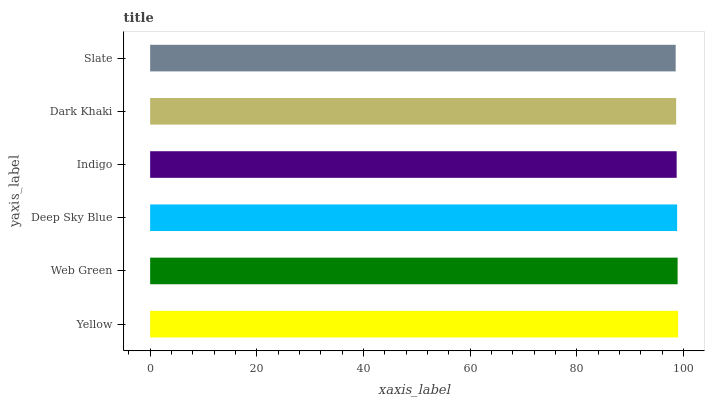Is Slate the minimum?
Answer yes or no. Yes. Is Yellow the maximum?
Answer yes or no. Yes. Is Web Green the minimum?
Answer yes or no. No. Is Web Green the maximum?
Answer yes or no. No. Is Yellow greater than Web Green?
Answer yes or no. Yes. Is Web Green less than Yellow?
Answer yes or no. Yes. Is Web Green greater than Yellow?
Answer yes or no. No. Is Yellow less than Web Green?
Answer yes or no. No. Is Deep Sky Blue the high median?
Answer yes or no. Yes. Is Indigo the low median?
Answer yes or no. Yes. Is Web Green the high median?
Answer yes or no. No. Is Dark Khaki the low median?
Answer yes or no. No. 